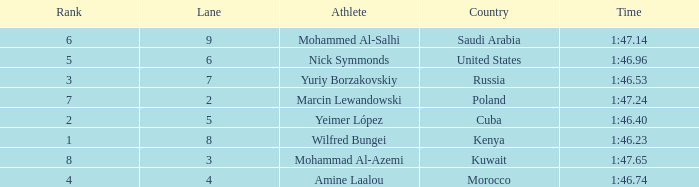What is the placement of the sportsman with a time of 1:4 None. 